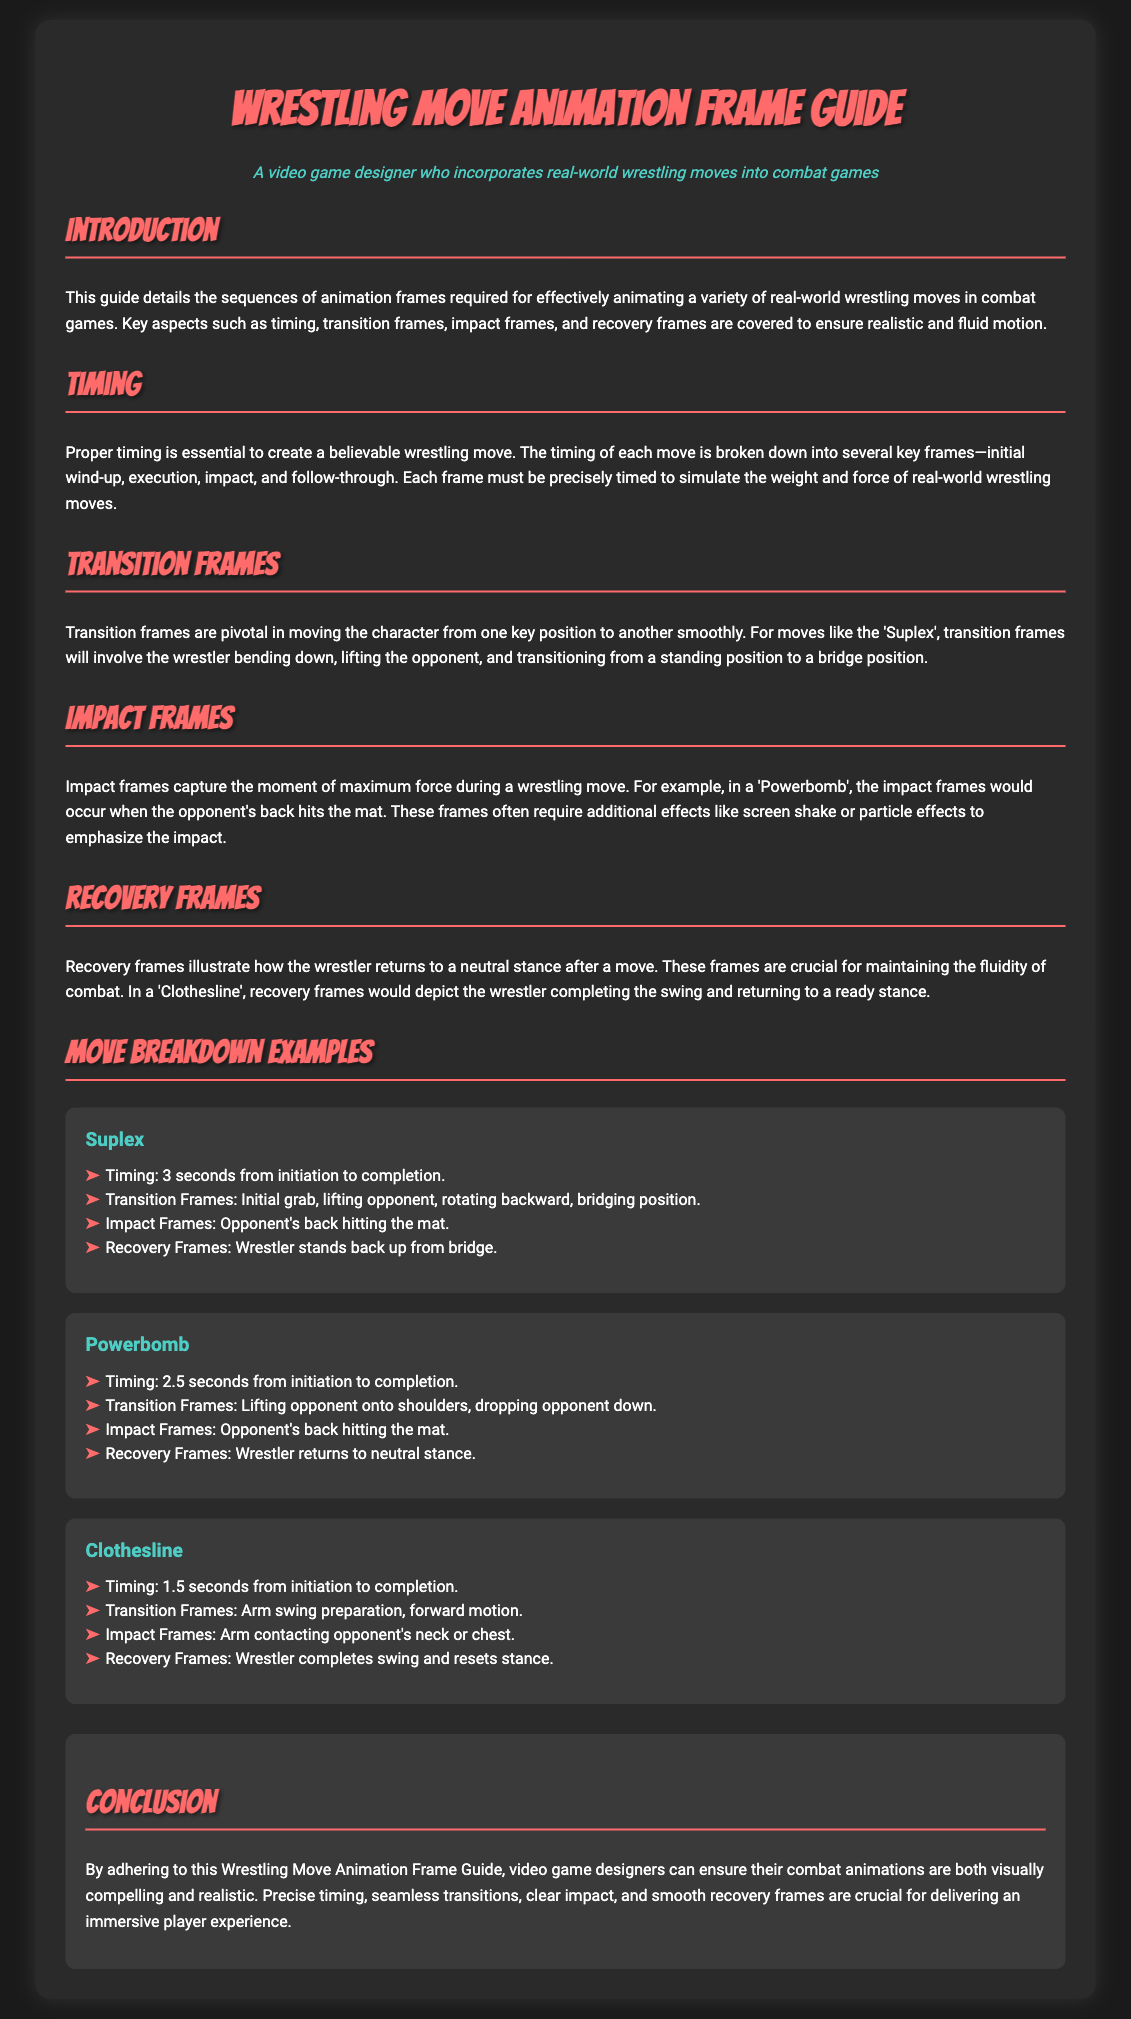What is the title of the document? The title of the document is presented prominently at the top of the rendered document.
Answer: Wrestling Move Animation Frame Guide What is covered in the introduction? The introduction outlines the purpose of the guide for animating wrestling moves in combat games.
Answer: Animation frames for wrestling moves How many seconds does a 'Suplex' take from initiation to completion? The timing for the 'Suplex' move is indicated in the breakdown of examples.
Answer: 3 seconds What is an example of an impact frame for a 'Powerbomb'? The impact frame description for the 'Powerbomb' specifies the event when the opponent's back hits the mat.
Answer: Opponent's back hitting the mat How many types of frames are discussed in the document? The document lists several types of frames relevant to wrestling moves.
Answer: Four types What does the guide emphasize for realistic animations? The guide includes a specific aspect that is crucial for creating believable wrestling animations.
Answer: Precise timing How does the 'Clothesline' recovery frame end? The recovery frames for 'Clothesline' describe how the wrestler returns after the move.
Answer: Wrestler completes swing and resets stance What color is used in the headings of the document? The headings and titles stand out with a specific color mentioned through the styling in the document.
Answer: #ff6b6b How many wrestling moves are broken down as examples? The document specifically lists the number of wrestling moves for detailed breakdown.
Answer: Three moves 